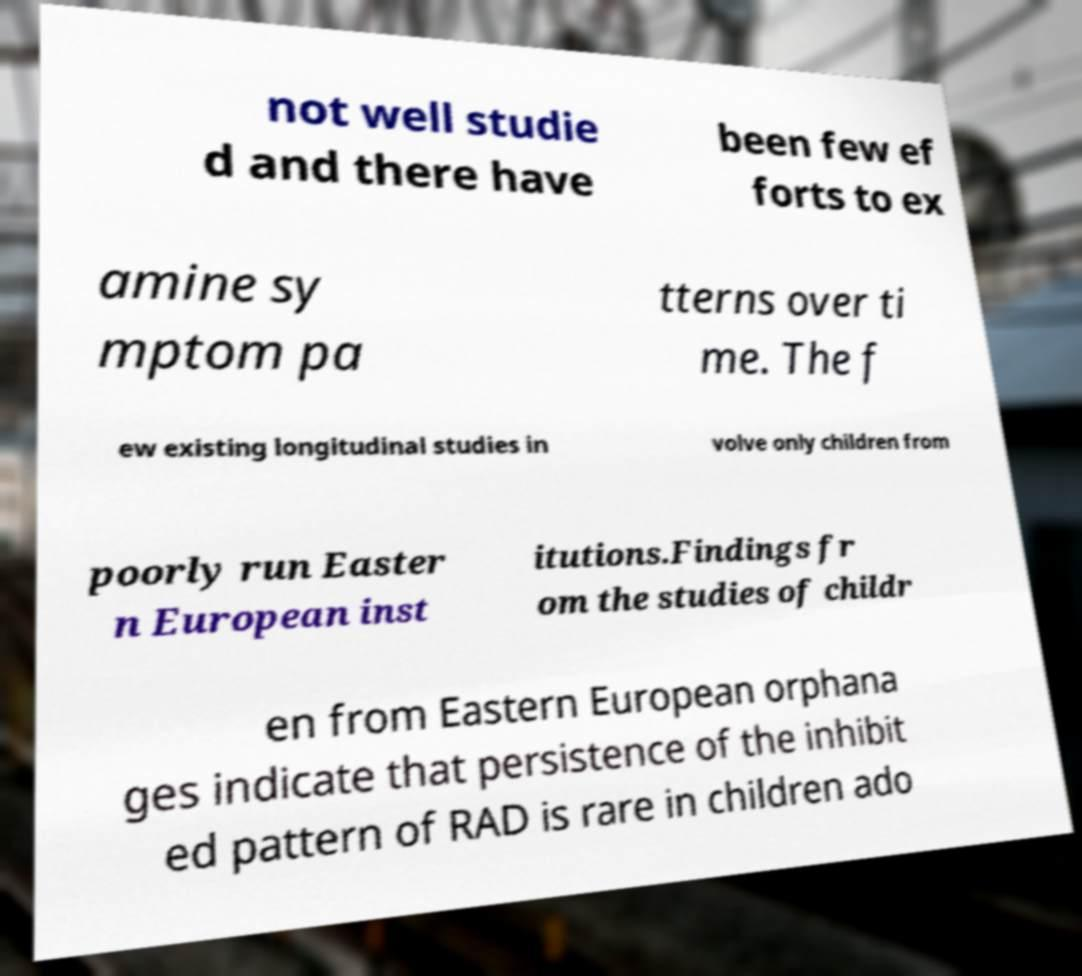I need the written content from this picture converted into text. Can you do that? not well studie d and there have been few ef forts to ex amine sy mptom pa tterns over ti me. The f ew existing longitudinal studies in volve only children from poorly run Easter n European inst itutions.Findings fr om the studies of childr en from Eastern European orphana ges indicate that persistence of the inhibit ed pattern of RAD is rare in children ado 